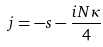<formula> <loc_0><loc_0><loc_500><loc_500>j = - s - \frac { i N \kappa } { 4 }</formula> 